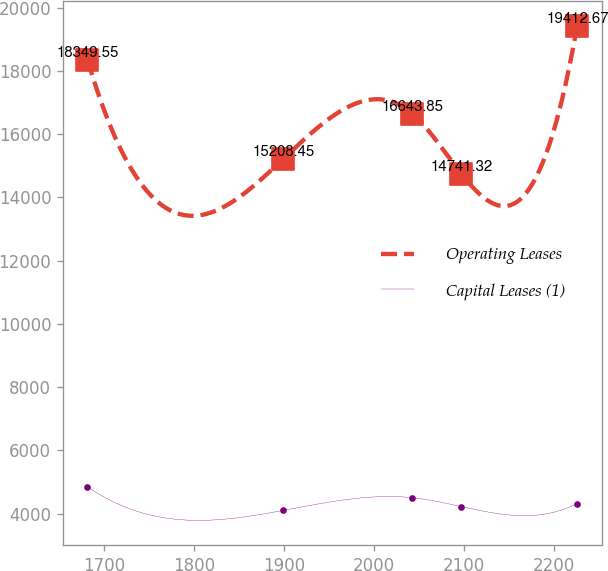Convert chart to OTSL. <chart><loc_0><loc_0><loc_500><loc_500><line_chart><ecel><fcel>Operating Leases<fcel>Capital Leases (1)<nl><fcel>1681.08<fcel>18349.5<fcel>4848.2<nl><fcel>1898.68<fcel>15208.5<fcel>4097.51<nl><fcel>2042.36<fcel>16643.8<fcel>4500.13<nl><fcel>2096.81<fcel>14741.3<fcel>4218.23<nl><fcel>2225.55<fcel>19412.7<fcel>4312.24<nl></chart> 